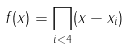Convert formula to latex. <formula><loc_0><loc_0><loc_500><loc_500>f ( x ) = \prod _ { i < 4 } ( x - x _ { i } )</formula> 